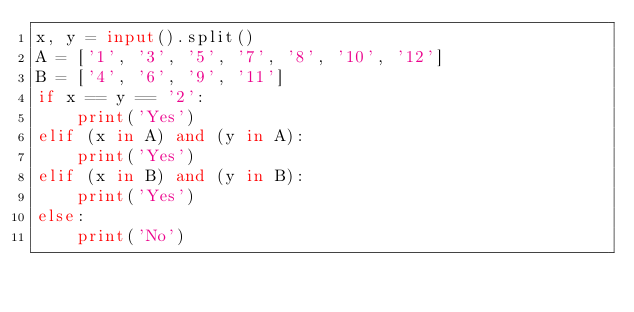Convert code to text. <code><loc_0><loc_0><loc_500><loc_500><_Python_>x, y = input().split()
A = ['1', '3', '5', '7', '8', '10', '12']
B = ['4', '6', '9', '11']
if x == y == '2':
    print('Yes')
elif (x in A) and (y in A):
    print('Yes')
elif (x in B) and (y in B):
    print('Yes')
else:
    print('No')</code> 